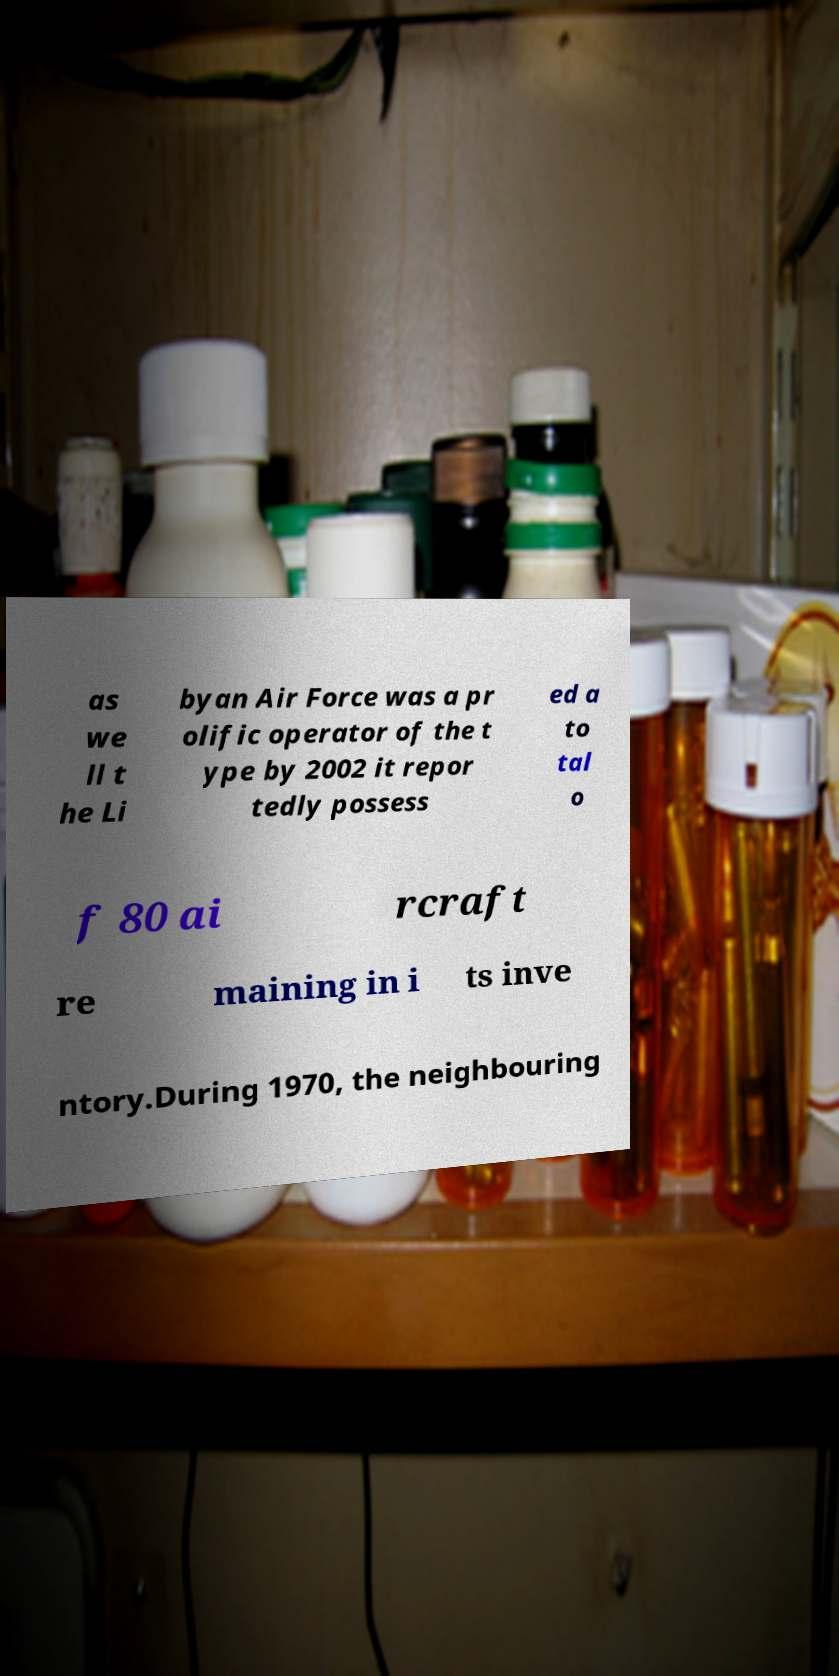Please read and relay the text visible in this image. What does it say? as we ll t he Li byan Air Force was a pr olific operator of the t ype by 2002 it repor tedly possess ed a to tal o f 80 ai rcraft re maining in i ts inve ntory.During 1970, the neighbouring 